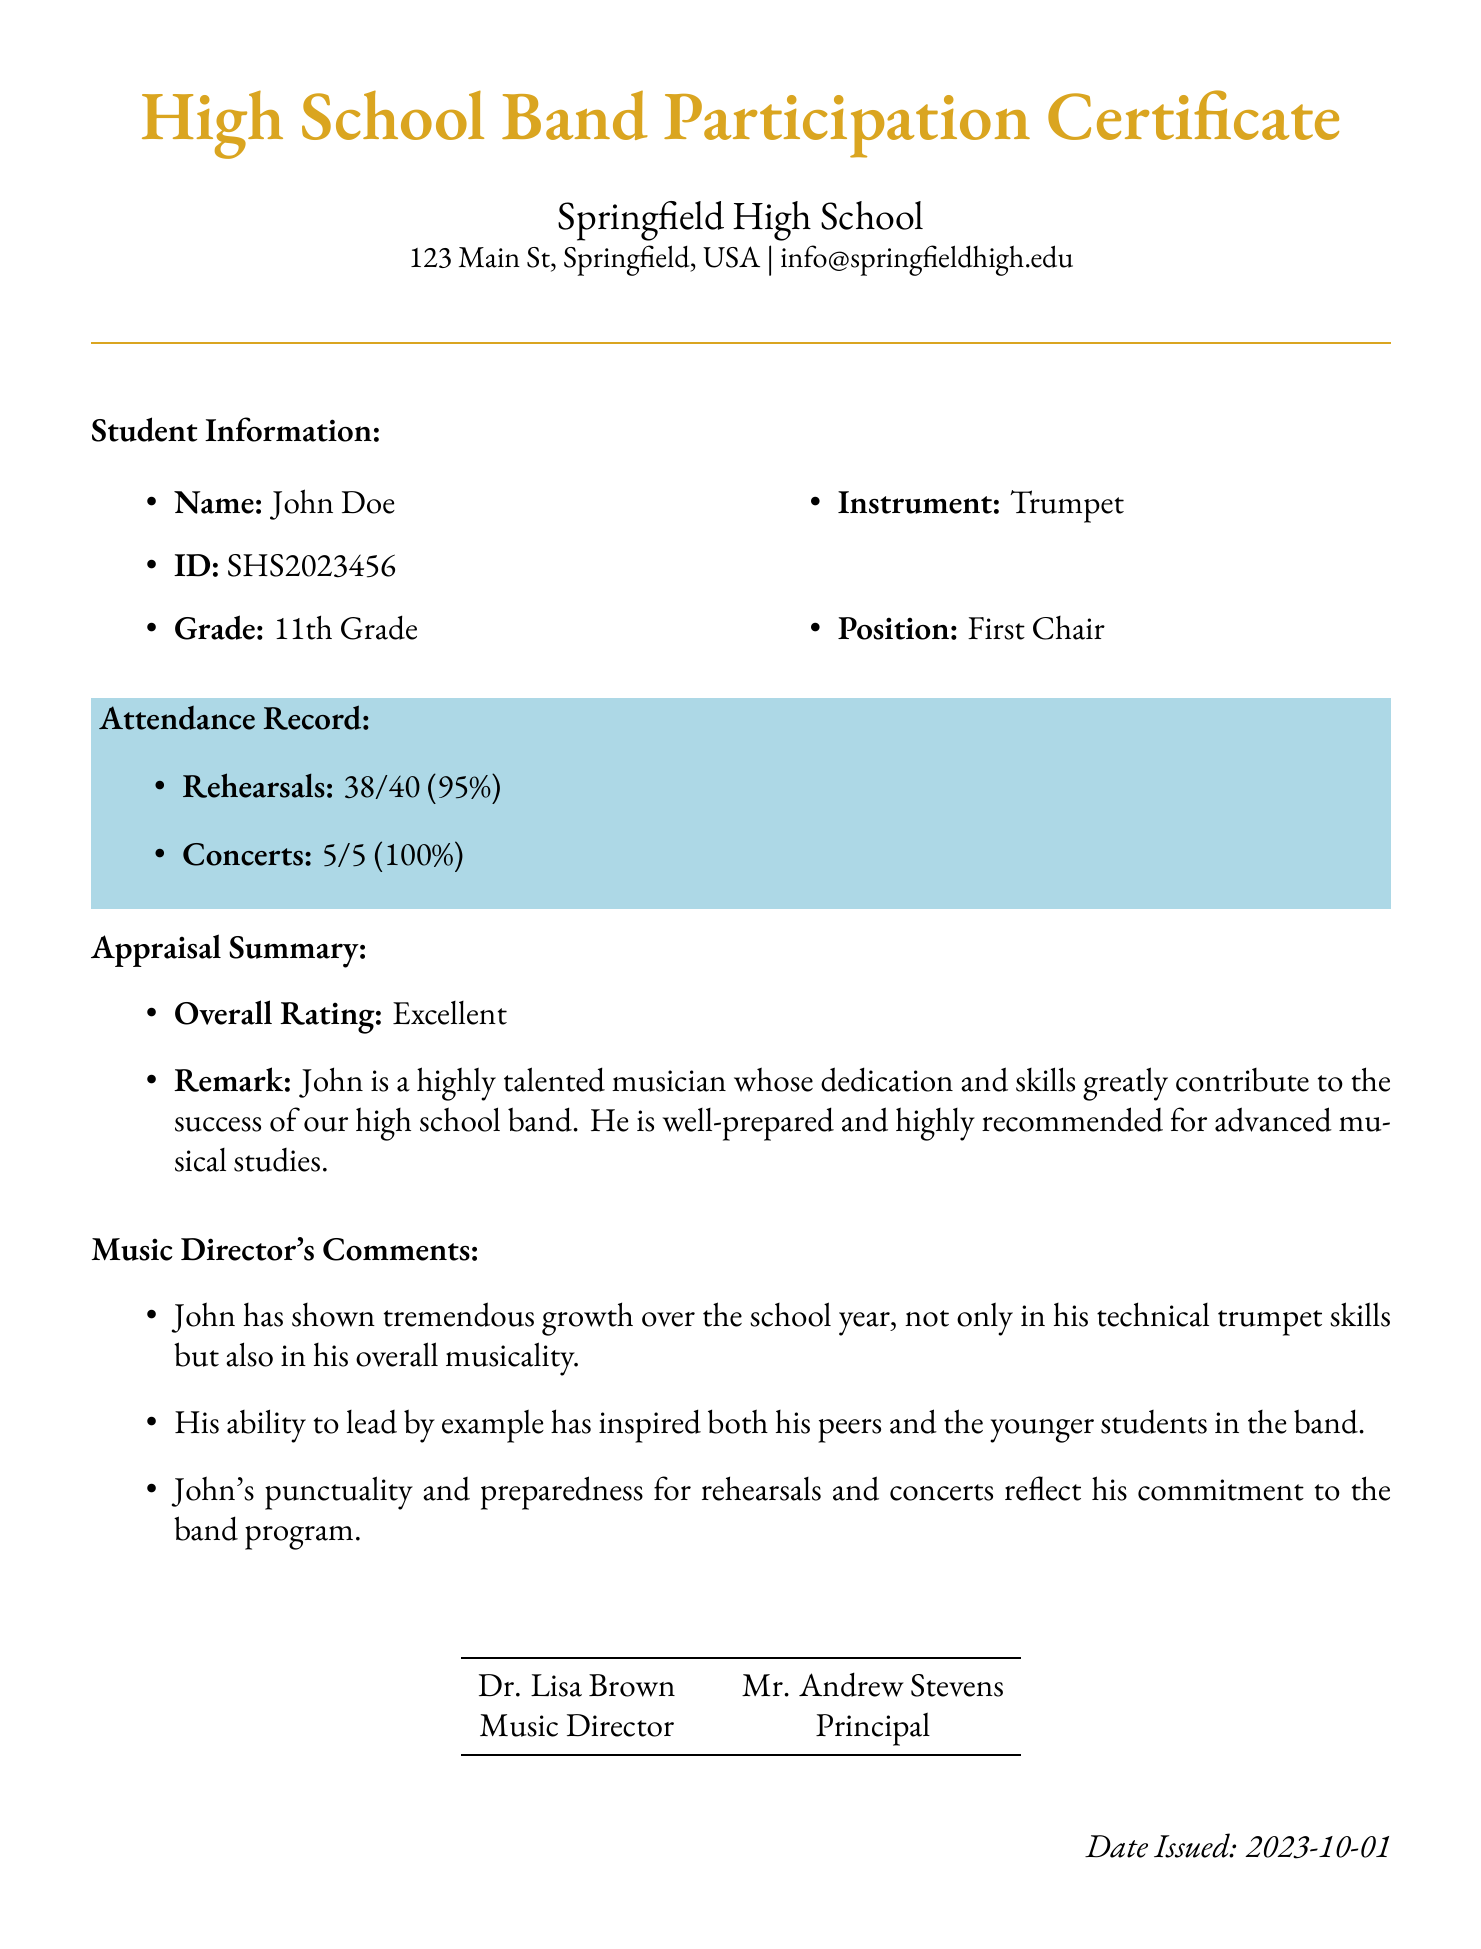What is the name of the student? The student's name is stated under Student Information in the document.
Answer: John Doe What is the student's ID? The student ID is provided in the document in the Student Information section.
Answer: SHS2023456 How many rehearsals did the student attend? The attendance record shows the number of rehearsals attended by the student.
Answer: 38 What is the percentage of concerts attended? The attendance record indicates the percentage of concerts attended by the student.
Answer: 100% Who is the Music Director? The document lists the name of the Music Director at the bottom.
Answer: Dr. Lisa Brown What position does the student hold in the band? The student's position is mentioned in the Student Information section.
Answer: First Chair What is the overall rating given to the student? The overall rating for the student is mentioned in the Appraisal Summary.
Answer: Excellent What date was the certificate issued? The date issued is found in the footer of the document.
Answer: 2023-10-01 How many concerts did the student perform in? The attendance record specifies the total number of concerts attended by the student.
Answer: 5 